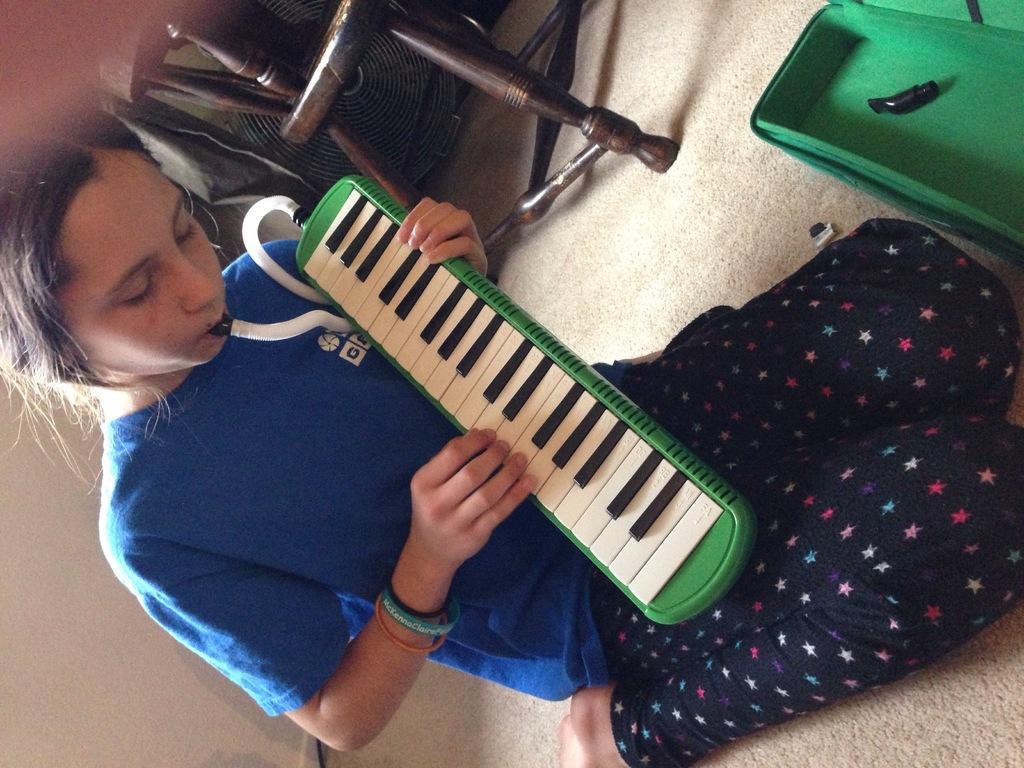Could you give a brief overview of what you see in this image? In this picture there is a woman sitting on the floor and playing a musical instrument, in front of her we can see box. In the background of the image we can see chair and objects. 